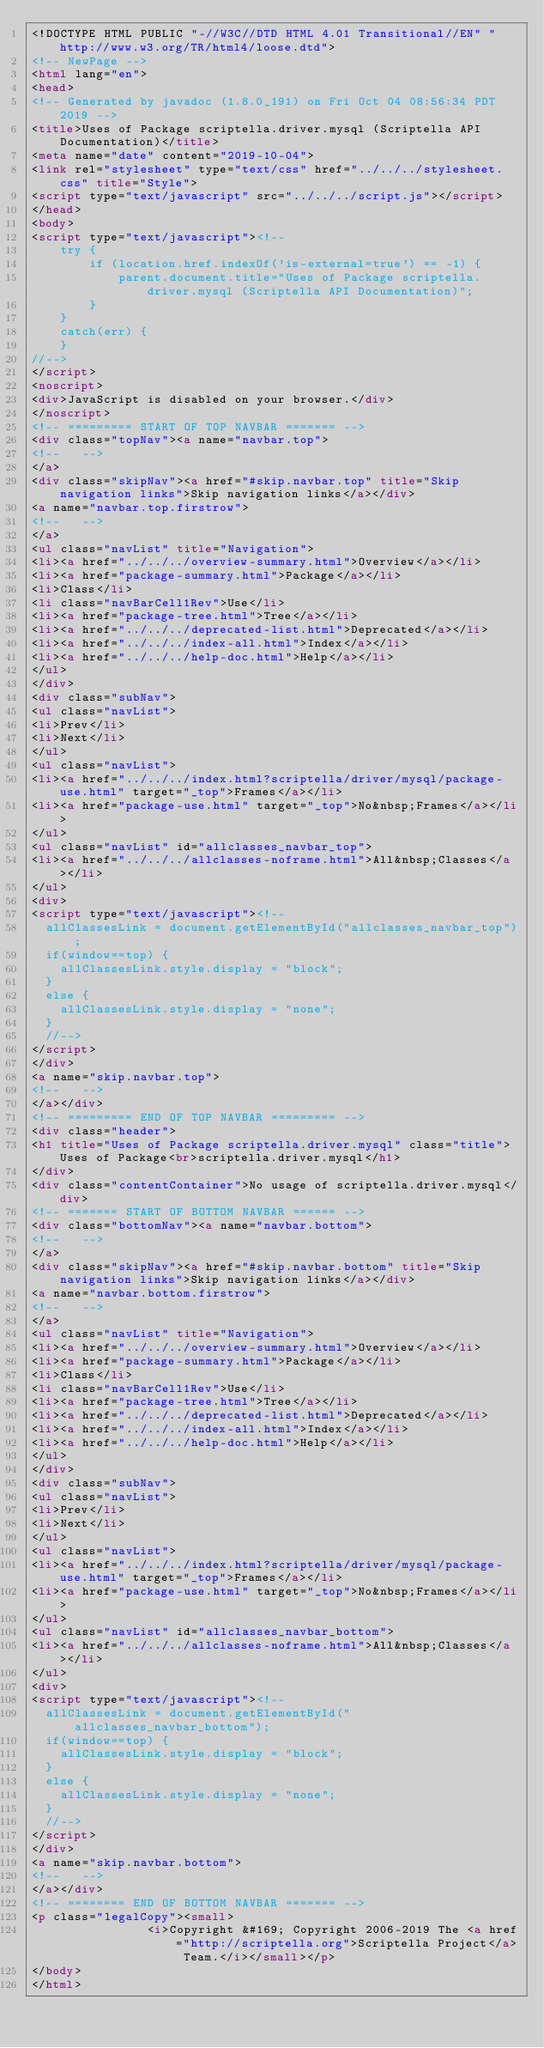<code> <loc_0><loc_0><loc_500><loc_500><_HTML_><!DOCTYPE HTML PUBLIC "-//W3C//DTD HTML 4.01 Transitional//EN" "http://www.w3.org/TR/html4/loose.dtd">
<!-- NewPage -->
<html lang="en">
<head>
<!-- Generated by javadoc (1.8.0_191) on Fri Oct 04 08:56:34 PDT 2019 -->
<title>Uses of Package scriptella.driver.mysql (Scriptella API Documentation)</title>
<meta name="date" content="2019-10-04">
<link rel="stylesheet" type="text/css" href="../../../stylesheet.css" title="Style">
<script type="text/javascript" src="../../../script.js"></script>
</head>
<body>
<script type="text/javascript"><!--
    try {
        if (location.href.indexOf('is-external=true') == -1) {
            parent.document.title="Uses of Package scriptella.driver.mysql (Scriptella API Documentation)";
        }
    }
    catch(err) {
    }
//-->
</script>
<noscript>
<div>JavaScript is disabled on your browser.</div>
</noscript>
<!-- ========= START OF TOP NAVBAR ======= -->
<div class="topNav"><a name="navbar.top">
<!--   -->
</a>
<div class="skipNav"><a href="#skip.navbar.top" title="Skip navigation links">Skip navigation links</a></div>
<a name="navbar.top.firstrow">
<!--   -->
</a>
<ul class="navList" title="Navigation">
<li><a href="../../../overview-summary.html">Overview</a></li>
<li><a href="package-summary.html">Package</a></li>
<li>Class</li>
<li class="navBarCell1Rev">Use</li>
<li><a href="package-tree.html">Tree</a></li>
<li><a href="../../../deprecated-list.html">Deprecated</a></li>
<li><a href="../../../index-all.html">Index</a></li>
<li><a href="../../../help-doc.html">Help</a></li>
</ul>
</div>
<div class="subNav">
<ul class="navList">
<li>Prev</li>
<li>Next</li>
</ul>
<ul class="navList">
<li><a href="../../../index.html?scriptella/driver/mysql/package-use.html" target="_top">Frames</a></li>
<li><a href="package-use.html" target="_top">No&nbsp;Frames</a></li>
</ul>
<ul class="navList" id="allclasses_navbar_top">
<li><a href="../../../allclasses-noframe.html">All&nbsp;Classes</a></li>
</ul>
<div>
<script type="text/javascript"><!--
  allClassesLink = document.getElementById("allclasses_navbar_top");
  if(window==top) {
    allClassesLink.style.display = "block";
  }
  else {
    allClassesLink.style.display = "none";
  }
  //-->
</script>
</div>
<a name="skip.navbar.top">
<!--   -->
</a></div>
<!-- ========= END OF TOP NAVBAR ========= -->
<div class="header">
<h1 title="Uses of Package scriptella.driver.mysql" class="title">Uses of Package<br>scriptella.driver.mysql</h1>
</div>
<div class="contentContainer">No usage of scriptella.driver.mysql</div>
<!-- ======= START OF BOTTOM NAVBAR ====== -->
<div class="bottomNav"><a name="navbar.bottom">
<!--   -->
</a>
<div class="skipNav"><a href="#skip.navbar.bottom" title="Skip navigation links">Skip navigation links</a></div>
<a name="navbar.bottom.firstrow">
<!--   -->
</a>
<ul class="navList" title="Navigation">
<li><a href="../../../overview-summary.html">Overview</a></li>
<li><a href="package-summary.html">Package</a></li>
<li>Class</li>
<li class="navBarCell1Rev">Use</li>
<li><a href="package-tree.html">Tree</a></li>
<li><a href="../../../deprecated-list.html">Deprecated</a></li>
<li><a href="../../../index-all.html">Index</a></li>
<li><a href="../../../help-doc.html">Help</a></li>
</ul>
</div>
<div class="subNav">
<ul class="navList">
<li>Prev</li>
<li>Next</li>
</ul>
<ul class="navList">
<li><a href="../../../index.html?scriptella/driver/mysql/package-use.html" target="_top">Frames</a></li>
<li><a href="package-use.html" target="_top">No&nbsp;Frames</a></li>
</ul>
<ul class="navList" id="allclasses_navbar_bottom">
<li><a href="../../../allclasses-noframe.html">All&nbsp;Classes</a></li>
</ul>
<div>
<script type="text/javascript"><!--
  allClassesLink = document.getElementById("allclasses_navbar_bottom");
  if(window==top) {
    allClassesLink.style.display = "block";
  }
  else {
    allClassesLink.style.display = "none";
  }
  //-->
</script>
</div>
<a name="skip.navbar.bottom">
<!--   -->
</a></div>
<!-- ======== END OF BOTTOM NAVBAR ======= -->
<p class="legalCopy"><small>
                <i>Copyright &#169; Copyright 2006-2019 The <a href="http://scriptella.org">Scriptella Project</a> Team.</i></small></p>
</body>
</html>
</code> 